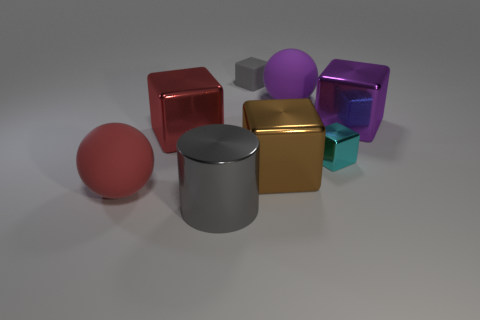Add 2 big brown things. How many objects exist? 10 Subtract all small cyan cubes. How many cubes are left? 4 Subtract all red cubes. How many cubes are left? 4 Subtract all green spheres. How many yellow blocks are left? 0 Subtract all big purple matte objects. Subtract all large purple matte balls. How many objects are left? 6 Add 5 large purple shiny blocks. How many large purple shiny blocks are left? 6 Add 3 gray cylinders. How many gray cylinders exist? 4 Subtract 0 green cylinders. How many objects are left? 8 Subtract all spheres. How many objects are left? 6 Subtract all blue spheres. Subtract all red cubes. How many spheres are left? 2 